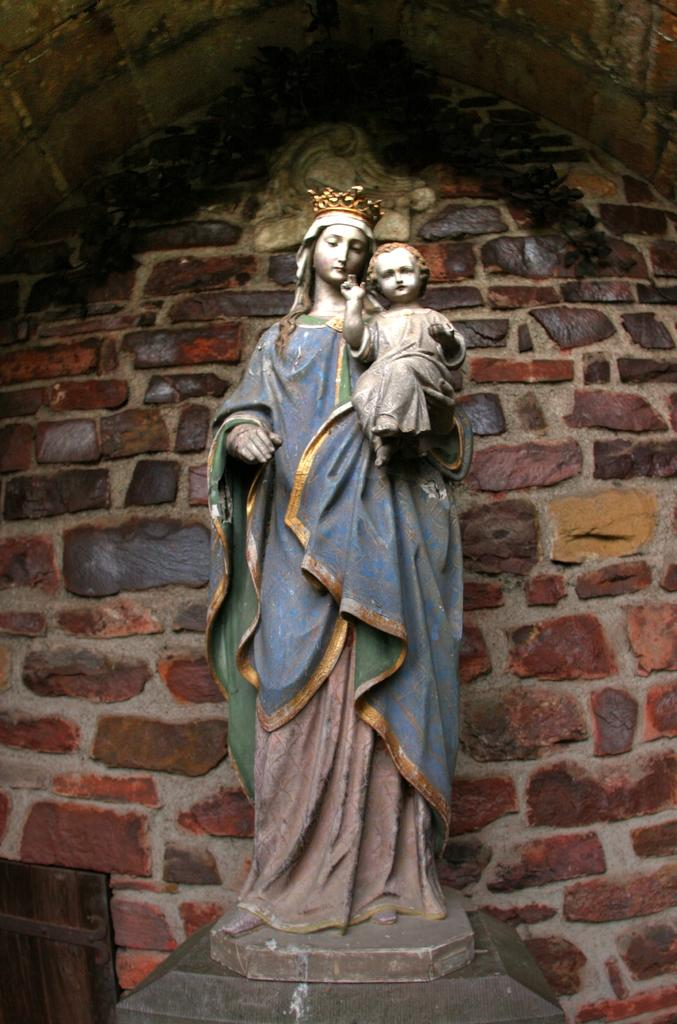What is the main subject of the image? The main subject of the image is a statue of a woman. What is the statue holding in her hand? The statue has a boy in her hand. What is on the statue's head? The statue has a crown on her head. What can be seen in the background of the image? There is a wall in the background of the image. What type of wood is the maid using to clean the floor in the image? There is no maid or wood present in the image; it features a statue of a woman with a boy in her hand and a crown on her head, with a wall in the background. 